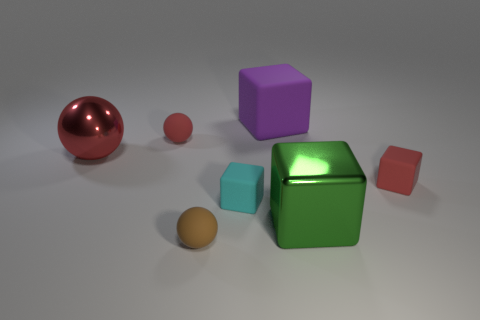Add 1 purple cubes. How many objects exist? 8 Subtract all green cubes. How many cubes are left? 3 Subtract all green blocks. How many blocks are left? 3 Subtract all brown blocks. How many red spheres are left? 2 Subtract 1 spheres. How many spheres are left? 2 Add 6 tiny cyan matte things. How many tiny cyan matte things are left? 7 Add 4 purple matte things. How many purple matte things exist? 5 Subtract 0 gray blocks. How many objects are left? 7 Subtract all balls. How many objects are left? 4 Subtract all green spheres. Subtract all yellow blocks. How many spheres are left? 3 